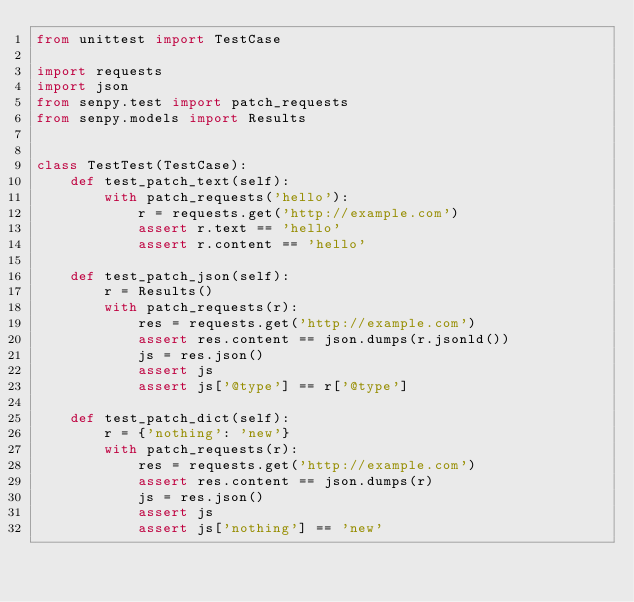<code> <loc_0><loc_0><loc_500><loc_500><_Python_>from unittest import TestCase

import requests
import json
from senpy.test import patch_requests
from senpy.models import Results


class TestTest(TestCase):
    def test_patch_text(self):
        with patch_requests('hello'):
            r = requests.get('http://example.com')
            assert r.text == 'hello'
            assert r.content == 'hello'

    def test_patch_json(self):
        r = Results()
        with patch_requests(r):
            res = requests.get('http://example.com')
            assert res.content == json.dumps(r.jsonld())
            js = res.json()
            assert js
            assert js['@type'] == r['@type']

    def test_patch_dict(self):
        r = {'nothing': 'new'}
        with patch_requests(r):
            res = requests.get('http://example.com')
            assert res.content == json.dumps(r)
            js = res.json()
            assert js
            assert js['nothing'] == 'new'
</code> 